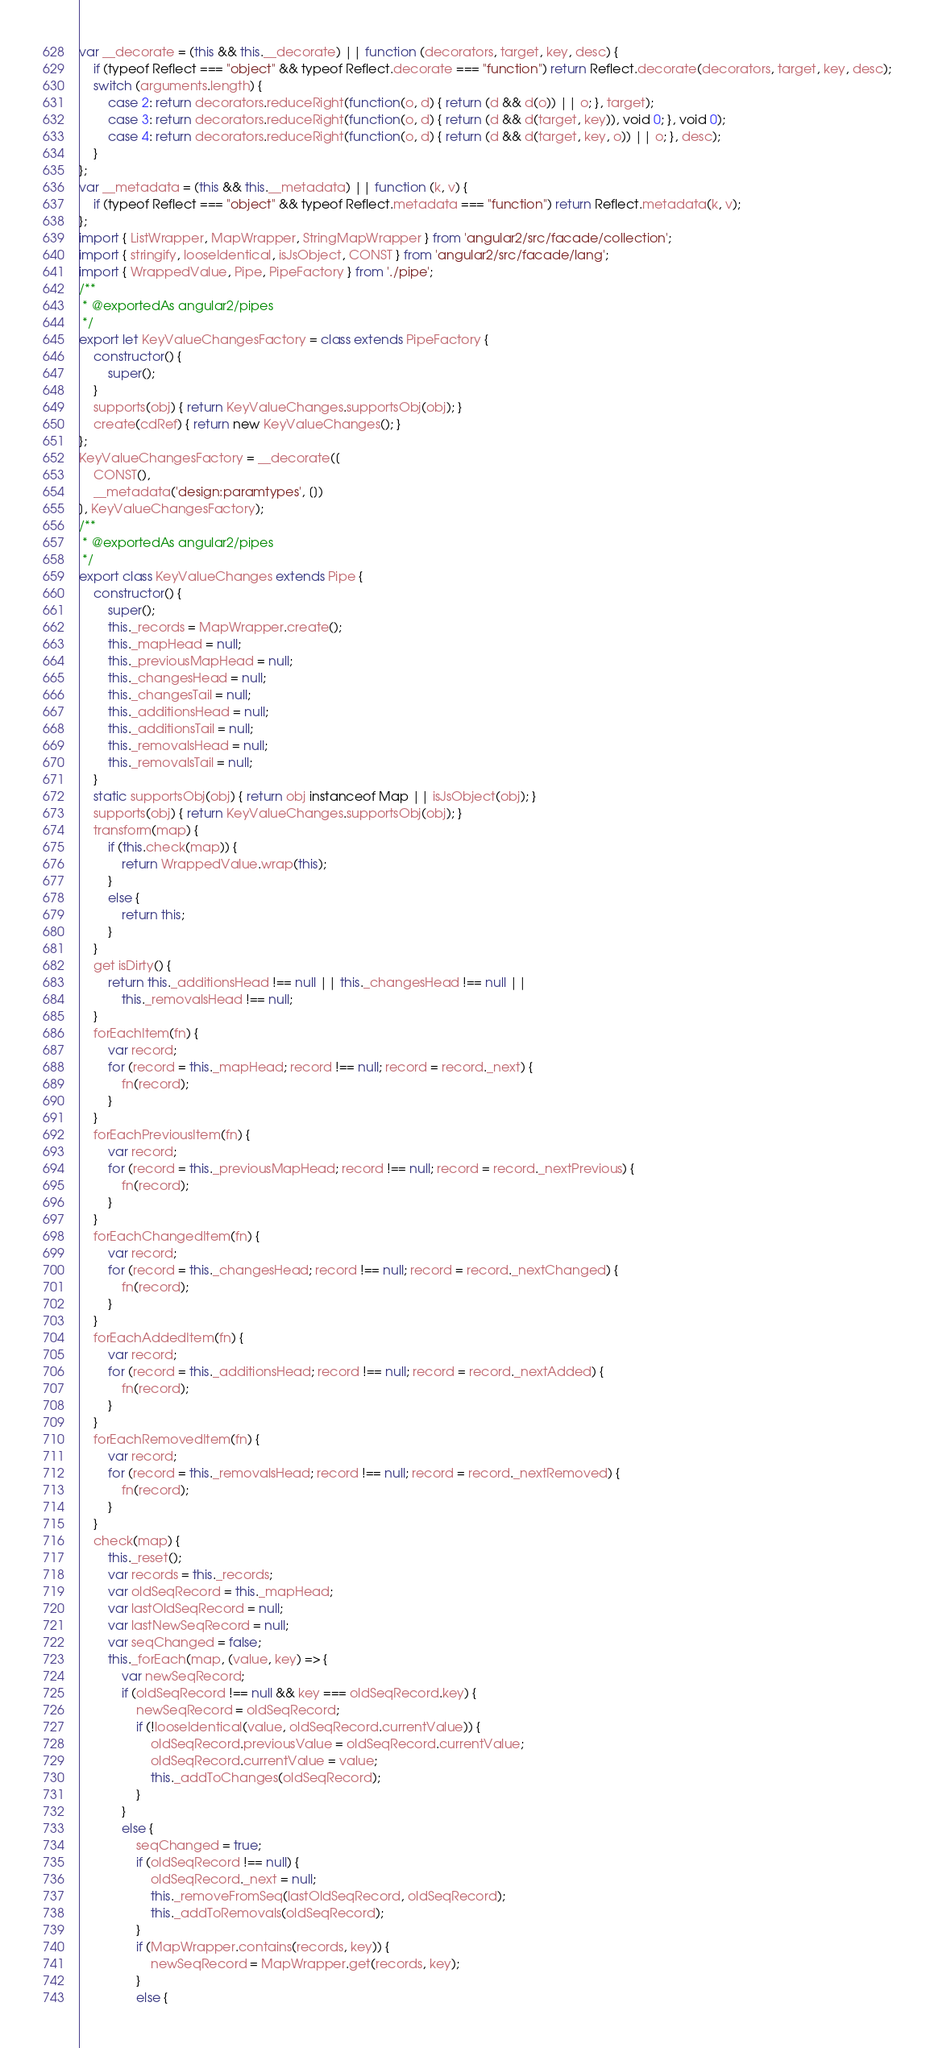Convert code to text. <code><loc_0><loc_0><loc_500><loc_500><_JavaScript_>var __decorate = (this && this.__decorate) || function (decorators, target, key, desc) {
    if (typeof Reflect === "object" && typeof Reflect.decorate === "function") return Reflect.decorate(decorators, target, key, desc);
    switch (arguments.length) {
        case 2: return decorators.reduceRight(function(o, d) { return (d && d(o)) || o; }, target);
        case 3: return decorators.reduceRight(function(o, d) { return (d && d(target, key)), void 0; }, void 0);
        case 4: return decorators.reduceRight(function(o, d) { return (d && d(target, key, o)) || o; }, desc);
    }
};
var __metadata = (this && this.__metadata) || function (k, v) {
    if (typeof Reflect === "object" && typeof Reflect.metadata === "function") return Reflect.metadata(k, v);
};
import { ListWrapper, MapWrapper, StringMapWrapper } from 'angular2/src/facade/collection';
import { stringify, looseIdentical, isJsObject, CONST } from 'angular2/src/facade/lang';
import { WrappedValue, Pipe, PipeFactory } from './pipe';
/**
 * @exportedAs angular2/pipes
 */
export let KeyValueChangesFactory = class extends PipeFactory {
    constructor() {
        super();
    }
    supports(obj) { return KeyValueChanges.supportsObj(obj); }
    create(cdRef) { return new KeyValueChanges(); }
};
KeyValueChangesFactory = __decorate([
    CONST(), 
    __metadata('design:paramtypes', [])
], KeyValueChangesFactory);
/**
 * @exportedAs angular2/pipes
 */
export class KeyValueChanges extends Pipe {
    constructor() {
        super();
        this._records = MapWrapper.create();
        this._mapHead = null;
        this._previousMapHead = null;
        this._changesHead = null;
        this._changesTail = null;
        this._additionsHead = null;
        this._additionsTail = null;
        this._removalsHead = null;
        this._removalsTail = null;
    }
    static supportsObj(obj) { return obj instanceof Map || isJsObject(obj); }
    supports(obj) { return KeyValueChanges.supportsObj(obj); }
    transform(map) {
        if (this.check(map)) {
            return WrappedValue.wrap(this);
        }
        else {
            return this;
        }
    }
    get isDirty() {
        return this._additionsHead !== null || this._changesHead !== null ||
            this._removalsHead !== null;
    }
    forEachItem(fn) {
        var record;
        for (record = this._mapHead; record !== null; record = record._next) {
            fn(record);
        }
    }
    forEachPreviousItem(fn) {
        var record;
        for (record = this._previousMapHead; record !== null; record = record._nextPrevious) {
            fn(record);
        }
    }
    forEachChangedItem(fn) {
        var record;
        for (record = this._changesHead; record !== null; record = record._nextChanged) {
            fn(record);
        }
    }
    forEachAddedItem(fn) {
        var record;
        for (record = this._additionsHead; record !== null; record = record._nextAdded) {
            fn(record);
        }
    }
    forEachRemovedItem(fn) {
        var record;
        for (record = this._removalsHead; record !== null; record = record._nextRemoved) {
            fn(record);
        }
    }
    check(map) {
        this._reset();
        var records = this._records;
        var oldSeqRecord = this._mapHead;
        var lastOldSeqRecord = null;
        var lastNewSeqRecord = null;
        var seqChanged = false;
        this._forEach(map, (value, key) => {
            var newSeqRecord;
            if (oldSeqRecord !== null && key === oldSeqRecord.key) {
                newSeqRecord = oldSeqRecord;
                if (!looseIdentical(value, oldSeqRecord.currentValue)) {
                    oldSeqRecord.previousValue = oldSeqRecord.currentValue;
                    oldSeqRecord.currentValue = value;
                    this._addToChanges(oldSeqRecord);
                }
            }
            else {
                seqChanged = true;
                if (oldSeqRecord !== null) {
                    oldSeqRecord._next = null;
                    this._removeFromSeq(lastOldSeqRecord, oldSeqRecord);
                    this._addToRemovals(oldSeqRecord);
                }
                if (MapWrapper.contains(records, key)) {
                    newSeqRecord = MapWrapper.get(records, key);
                }
                else {</code> 